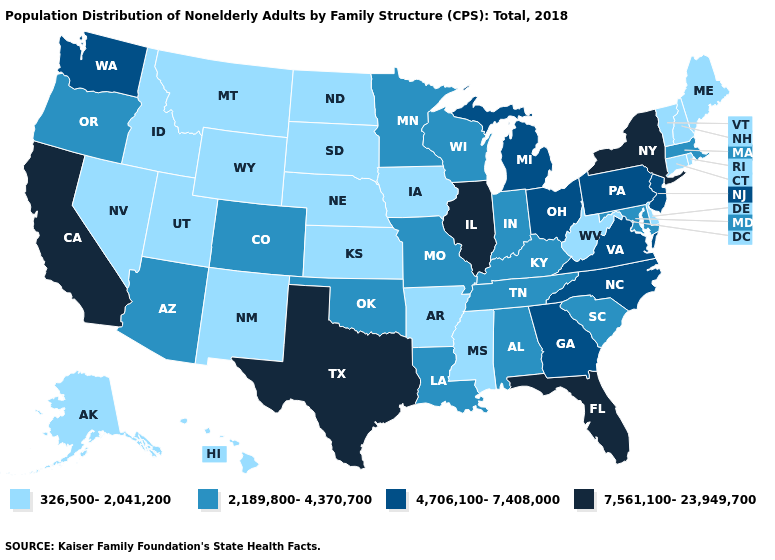Does the first symbol in the legend represent the smallest category?
Keep it brief. Yes. What is the highest value in states that border Delaware?
Quick response, please. 4,706,100-7,408,000. Does New York have the highest value in the Northeast?
Answer briefly. Yes. What is the value of Alaska?
Keep it brief. 326,500-2,041,200. Does North Carolina have the highest value in the USA?
Concise answer only. No. Which states have the lowest value in the Northeast?
Quick response, please. Connecticut, Maine, New Hampshire, Rhode Island, Vermont. Which states have the lowest value in the Northeast?
Concise answer only. Connecticut, Maine, New Hampshire, Rhode Island, Vermont. What is the value of South Dakota?
Write a very short answer. 326,500-2,041,200. What is the value of Montana?
Give a very brief answer. 326,500-2,041,200. Does Hawaii have the highest value in the USA?
Short answer required. No. Name the states that have a value in the range 326,500-2,041,200?
Give a very brief answer. Alaska, Arkansas, Connecticut, Delaware, Hawaii, Idaho, Iowa, Kansas, Maine, Mississippi, Montana, Nebraska, Nevada, New Hampshire, New Mexico, North Dakota, Rhode Island, South Dakota, Utah, Vermont, West Virginia, Wyoming. What is the highest value in states that border Connecticut?
Write a very short answer. 7,561,100-23,949,700. Which states have the lowest value in the West?
Keep it brief. Alaska, Hawaii, Idaho, Montana, Nevada, New Mexico, Utah, Wyoming. What is the highest value in the MidWest ?
Answer briefly. 7,561,100-23,949,700. 